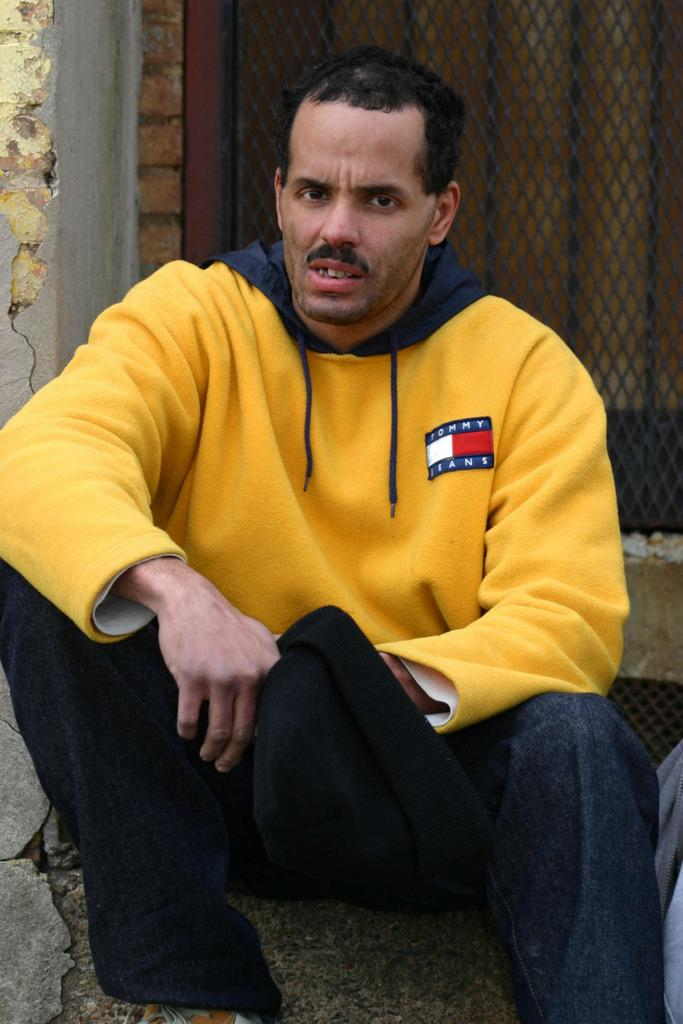Provide a one-sentence caption for the provided image. A man with a Tommy Jeans, yellow sweatshirt is sitting down outside holding a hat in his hand. 